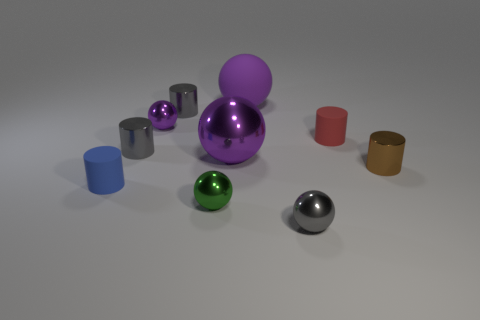Can you describe the lighting in the scene? The scene is lit with a soft, diffused light source that creates gentle shadows on the ground. It appears to be coming from above, as indicated by the direction of the shadows. The reflections on the metallic objects also suggest there may be multiple light sources, or a broad one, contributing to the even illumination of the scene. 